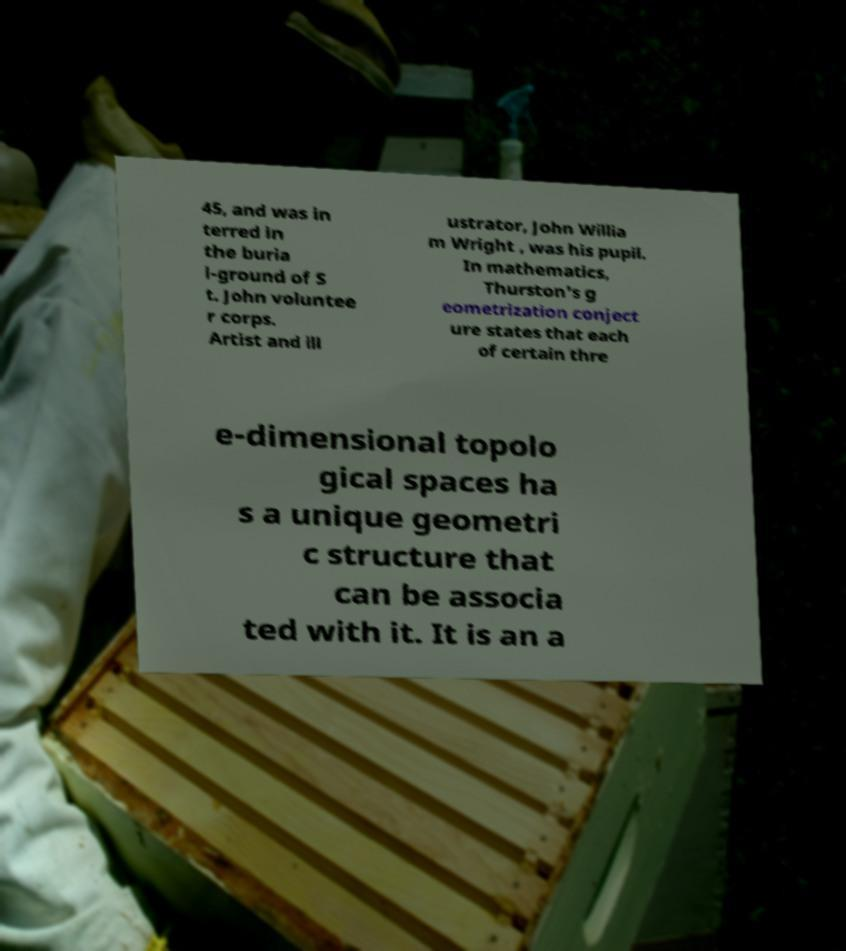Could you extract and type out the text from this image? 45, and was in terred in the buria l-ground of S t. John voluntee r corps. Artist and ill ustrator, John Willia m Wright , was his pupil. In mathematics, Thurston's g eometrization conject ure states that each of certain thre e-dimensional topolo gical spaces ha s a unique geometri c structure that can be associa ted with it. It is an a 